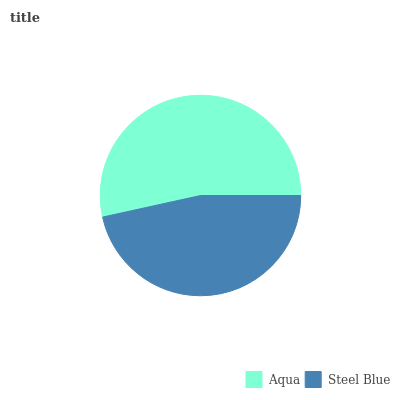Is Steel Blue the minimum?
Answer yes or no. Yes. Is Aqua the maximum?
Answer yes or no. Yes. Is Steel Blue the maximum?
Answer yes or no. No. Is Aqua greater than Steel Blue?
Answer yes or no. Yes. Is Steel Blue less than Aqua?
Answer yes or no. Yes. Is Steel Blue greater than Aqua?
Answer yes or no. No. Is Aqua less than Steel Blue?
Answer yes or no. No. Is Aqua the high median?
Answer yes or no. Yes. Is Steel Blue the low median?
Answer yes or no. Yes. Is Steel Blue the high median?
Answer yes or no. No. Is Aqua the low median?
Answer yes or no. No. 